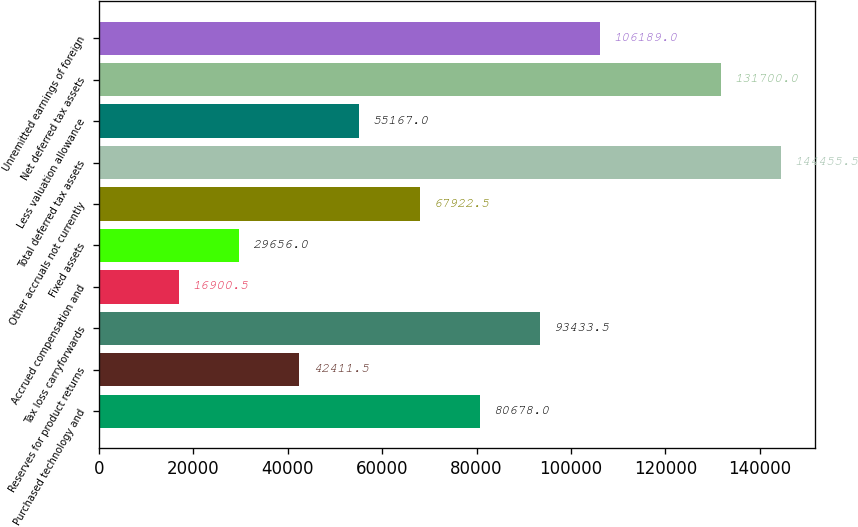Convert chart. <chart><loc_0><loc_0><loc_500><loc_500><bar_chart><fcel>Purchased technology and<fcel>Reserves for product returns<fcel>Tax loss carryforwards<fcel>Accrued compensation and<fcel>Fixed assets<fcel>Other accruals not currently<fcel>Total deferred tax assets<fcel>Less valuation allowance<fcel>Net deferred tax assets<fcel>Unremitted earnings of foreign<nl><fcel>80678<fcel>42411.5<fcel>93433.5<fcel>16900.5<fcel>29656<fcel>67922.5<fcel>144456<fcel>55167<fcel>131700<fcel>106189<nl></chart> 